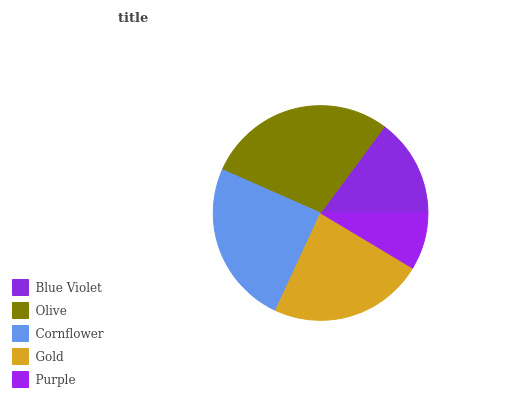Is Purple the minimum?
Answer yes or no. Yes. Is Olive the maximum?
Answer yes or no. Yes. Is Cornflower the minimum?
Answer yes or no. No. Is Cornflower the maximum?
Answer yes or no. No. Is Olive greater than Cornflower?
Answer yes or no. Yes. Is Cornflower less than Olive?
Answer yes or no. Yes. Is Cornflower greater than Olive?
Answer yes or no. No. Is Olive less than Cornflower?
Answer yes or no. No. Is Gold the high median?
Answer yes or no. Yes. Is Gold the low median?
Answer yes or no. Yes. Is Blue Violet the high median?
Answer yes or no. No. Is Blue Violet the low median?
Answer yes or no. No. 